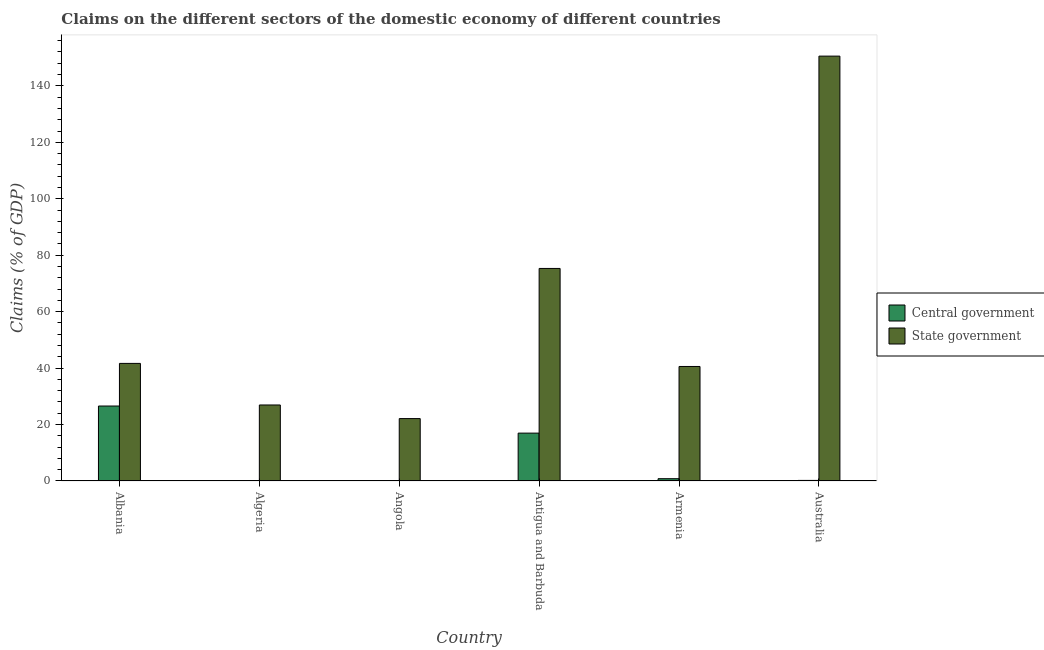Are the number of bars on each tick of the X-axis equal?
Your response must be concise. No. How many bars are there on the 2nd tick from the left?
Your response must be concise. 1. How many bars are there on the 5th tick from the right?
Your answer should be very brief. 1. What is the label of the 3rd group of bars from the left?
Keep it short and to the point. Angola. In how many cases, is the number of bars for a given country not equal to the number of legend labels?
Your answer should be very brief. 2. What is the claims on central government in Albania?
Make the answer very short. 26.56. Across all countries, what is the maximum claims on central government?
Ensure brevity in your answer.  26.56. Across all countries, what is the minimum claims on state government?
Your response must be concise. 22.11. In which country was the claims on state government maximum?
Give a very brief answer. Australia. What is the total claims on central government in the graph?
Your response must be concise. 44.54. What is the difference between the claims on state government in Angola and that in Australia?
Provide a succinct answer. -128.43. What is the difference between the claims on state government in Antigua and Barbuda and the claims on central government in Algeria?
Provide a succinct answer. 75.3. What is the average claims on central government per country?
Ensure brevity in your answer.  7.42. What is the difference between the claims on state government and claims on central government in Albania?
Your response must be concise. 15.1. What is the ratio of the claims on state government in Antigua and Barbuda to that in Australia?
Provide a succinct answer. 0.5. Is the claims on state government in Antigua and Barbuda less than that in Australia?
Your answer should be compact. Yes. Is the difference between the claims on state government in Antigua and Barbuda and Australia greater than the difference between the claims on central government in Antigua and Barbuda and Australia?
Provide a succinct answer. No. What is the difference between the highest and the second highest claims on central government?
Your answer should be very brief. 9.6. What is the difference between the highest and the lowest claims on central government?
Provide a succinct answer. 26.56. How many bars are there?
Ensure brevity in your answer.  10. Are all the bars in the graph horizontal?
Provide a succinct answer. No. What is the difference between two consecutive major ticks on the Y-axis?
Give a very brief answer. 20. Are the values on the major ticks of Y-axis written in scientific E-notation?
Offer a very short reply. No. Does the graph contain grids?
Provide a short and direct response. No. What is the title of the graph?
Your answer should be compact. Claims on the different sectors of the domestic economy of different countries. Does "constant 2005 US$" appear as one of the legend labels in the graph?
Your answer should be compact. No. What is the label or title of the X-axis?
Your response must be concise. Country. What is the label or title of the Y-axis?
Make the answer very short. Claims (% of GDP). What is the Claims (% of GDP) of Central government in Albania?
Your answer should be very brief. 26.56. What is the Claims (% of GDP) in State government in Albania?
Offer a terse response. 41.67. What is the Claims (% of GDP) of Central government in Algeria?
Provide a succinct answer. 0. What is the Claims (% of GDP) of State government in Algeria?
Offer a very short reply. 26.93. What is the Claims (% of GDP) of Central government in Angola?
Provide a succinct answer. 0. What is the Claims (% of GDP) in State government in Angola?
Make the answer very short. 22.11. What is the Claims (% of GDP) in Central government in Antigua and Barbuda?
Your answer should be very brief. 16.96. What is the Claims (% of GDP) in State government in Antigua and Barbuda?
Offer a terse response. 75.3. What is the Claims (% of GDP) in Central government in Armenia?
Offer a terse response. 0.81. What is the Claims (% of GDP) of State government in Armenia?
Give a very brief answer. 40.57. What is the Claims (% of GDP) of Central government in Australia?
Offer a very short reply. 0.2. What is the Claims (% of GDP) in State government in Australia?
Give a very brief answer. 150.53. Across all countries, what is the maximum Claims (% of GDP) in Central government?
Provide a short and direct response. 26.56. Across all countries, what is the maximum Claims (% of GDP) in State government?
Provide a short and direct response. 150.53. Across all countries, what is the minimum Claims (% of GDP) in Central government?
Offer a terse response. 0. Across all countries, what is the minimum Claims (% of GDP) in State government?
Your answer should be very brief. 22.11. What is the total Claims (% of GDP) of Central government in the graph?
Give a very brief answer. 44.54. What is the total Claims (% of GDP) in State government in the graph?
Provide a succinct answer. 357.12. What is the difference between the Claims (% of GDP) in State government in Albania and that in Algeria?
Provide a succinct answer. 14.73. What is the difference between the Claims (% of GDP) in State government in Albania and that in Angola?
Give a very brief answer. 19.56. What is the difference between the Claims (% of GDP) in Central government in Albania and that in Antigua and Barbuda?
Make the answer very short. 9.6. What is the difference between the Claims (% of GDP) in State government in Albania and that in Antigua and Barbuda?
Your answer should be very brief. -33.64. What is the difference between the Claims (% of GDP) in Central government in Albania and that in Armenia?
Offer a terse response. 25.75. What is the difference between the Claims (% of GDP) of State government in Albania and that in Armenia?
Provide a short and direct response. 1.09. What is the difference between the Claims (% of GDP) of Central government in Albania and that in Australia?
Offer a terse response. 26.36. What is the difference between the Claims (% of GDP) in State government in Albania and that in Australia?
Your response must be concise. -108.87. What is the difference between the Claims (% of GDP) in State government in Algeria and that in Angola?
Give a very brief answer. 4.83. What is the difference between the Claims (% of GDP) in State government in Algeria and that in Antigua and Barbuda?
Offer a very short reply. -48.37. What is the difference between the Claims (% of GDP) of State government in Algeria and that in Armenia?
Your response must be concise. -13.64. What is the difference between the Claims (% of GDP) in State government in Algeria and that in Australia?
Your answer should be compact. -123.6. What is the difference between the Claims (% of GDP) of State government in Angola and that in Antigua and Barbuda?
Offer a very short reply. -53.2. What is the difference between the Claims (% of GDP) of State government in Angola and that in Armenia?
Offer a terse response. -18.47. What is the difference between the Claims (% of GDP) of State government in Angola and that in Australia?
Make the answer very short. -128.43. What is the difference between the Claims (% of GDP) in Central government in Antigua and Barbuda and that in Armenia?
Offer a very short reply. 16.15. What is the difference between the Claims (% of GDP) of State government in Antigua and Barbuda and that in Armenia?
Your response must be concise. 34.73. What is the difference between the Claims (% of GDP) of Central government in Antigua and Barbuda and that in Australia?
Your answer should be very brief. 16.76. What is the difference between the Claims (% of GDP) of State government in Antigua and Barbuda and that in Australia?
Provide a short and direct response. -75.23. What is the difference between the Claims (% of GDP) in Central government in Armenia and that in Australia?
Keep it short and to the point. 0.61. What is the difference between the Claims (% of GDP) of State government in Armenia and that in Australia?
Your answer should be very brief. -109.96. What is the difference between the Claims (% of GDP) of Central government in Albania and the Claims (% of GDP) of State government in Algeria?
Give a very brief answer. -0.37. What is the difference between the Claims (% of GDP) in Central government in Albania and the Claims (% of GDP) in State government in Angola?
Your answer should be compact. 4.45. What is the difference between the Claims (% of GDP) of Central government in Albania and the Claims (% of GDP) of State government in Antigua and Barbuda?
Your answer should be compact. -48.74. What is the difference between the Claims (% of GDP) in Central government in Albania and the Claims (% of GDP) in State government in Armenia?
Your response must be concise. -14.01. What is the difference between the Claims (% of GDP) in Central government in Albania and the Claims (% of GDP) in State government in Australia?
Provide a short and direct response. -123.97. What is the difference between the Claims (% of GDP) of Central government in Antigua and Barbuda and the Claims (% of GDP) of State government in Armenia?
Offer a very short reply. -23.61. What is the difference between the Claims (% of GDP) of Central government in Antigua and Barbuda and the Claims (% of GDP) of State government in Australia?
Provide a short and direct response. -133.57. What is the difference between the Claims (% of GDP) in Central government in Armenia and the Claims (% of GDP) in State government in Australia?
Offer a terse response. -149.72. What is the average Claims (% of GDP) in Central government per country?
Your answer should be compact. 7.42. What is the average Claims (% of GDP) in State government per country?
Make the answer very short. 59.52. What is the difference between the Claims (% of GDP) in Central government and Claims (% of GDP) in State government in Albania?
Provide a short and direct response. -15.1. What is the difference between the Claims (% of GDP) in Central government and Claims (% of GDP) in State government in Antigua and Barbuda?
Ensure brevity in your answer.  -58.34. What is the difference between the Claims (% of GDP) in Central government and Claims (% of GDP) in State government in Armenia?
Offer a very short reply. -39.76. What is the difference between the Claims (% of GDP) in Central government and Claims (% of GDP) in State government in Australia?
Your answer should be very brief. -150.33. What is the ratio of the Claims (% of GDP) of State government in Albania to that in Algeria?
Your answer should be very brief. 1.55. What is the ratio of the Claims (% of GDP) of State government in Albania to that in Angola?
Make the answer very short. 1.88. What is the ratio of the Claims (% of GDP) in Central government in Albania to that in Antigua and Barbuda?
Your answer should be very brief. 1.57. What is the ratio of the Claims (% of GDP) of State government in Albania to that in Antigua and Barbuda?
Keep it short and to the point. 0.55. What is the ratio of the Claims (% of GDP) in Central government in Albania to that in Armenia?
Offer a terse response. 32.65. What is the ratio of the Claims (% of GDP) in State government in Albania to that in Armenia?
Your answer should be compact. 1.03. What is the ratio of the Claims (% of GDP) in Central government in Albania to that in Australia?
Your answer should be compact. 130.96. What is the ratio of the Claims (% of GDP) in State government in Albania to that in Australia?
Provide a short and direct response. 0.28. What is the ratio of the Claims (% of GDP) of State government in Algeria to that in Angola?
Give a very brief answer. 1.22. What is the ratio of the Claims (% of GDP) in State government in Algeria to that in Antigua and Barbuda?
Ensure brevity in your answer.  0.36. What is the ratio of the Claims (% of GDP) in State government in Algeria to that in Armenia?
Provide a succinct answer. 0.66. What is the ratio of the Claims (% of GDP) in State government in Algeria to that in Australia?
Ensure brevity in your answer.  0.18. What is the ratio of the Claims (% of GDP) in State government in Angola to that in Antigua and Barbuda?
Offer a terse response. 0.29. What is the ratio of the Claims (% of GDP) of State government in Angola to that in Armenia?
Provide a succinct answer. 0.54. What is the ratio of the Claims (% of GDP) in State government in Angola to that in Australia?
Offer a very short reply. 0.15. What is the ratio of the Claims (% of GDP) in Central government in Antigua and Barbuda to that in Armenia?
Keep it short and to the point. 20.85. What is the ratio of the Claims (% of GDP) in State government in Antigua and Barbuda to that in Armenia?
Keep it short and to the point. 1.86. What is the ratio of the Claims (% of GDP) in Central government in Antigua and Barbuda to that in Australia?
Keep it short and to the point. 83.63. What is the ratio of the Claims (% of GDP) of State government in Antigua and Barbuda to that in Australia?
Your answer should be very brief. 0.5. What is the ratio of the Claims (% of GDP) in Central government in Armenia to that in Australia?
Offer a very short reply. 4.01. What is the ratio of the Claims (% of GDP) of State government in Armenia to that in Australia?
Ensure brevity in your answer.  0.27. What is the difference between the highest and the second highest Claims (% of GDP) of Central government?
Keep it short and to the point. 9.6. What is the difference between the highest and the second highest Claims (% of GDP) of State government?
Your answer should be very brief. 75.23. What is the difference between the highest and the lowest Claims (% of GDP) of Central government?
Your answer should be compact. 26.56. What is the difference between the highest and the lowest Claims (% of GDP) in State government?
Provide a short and direct response. 128.43. 